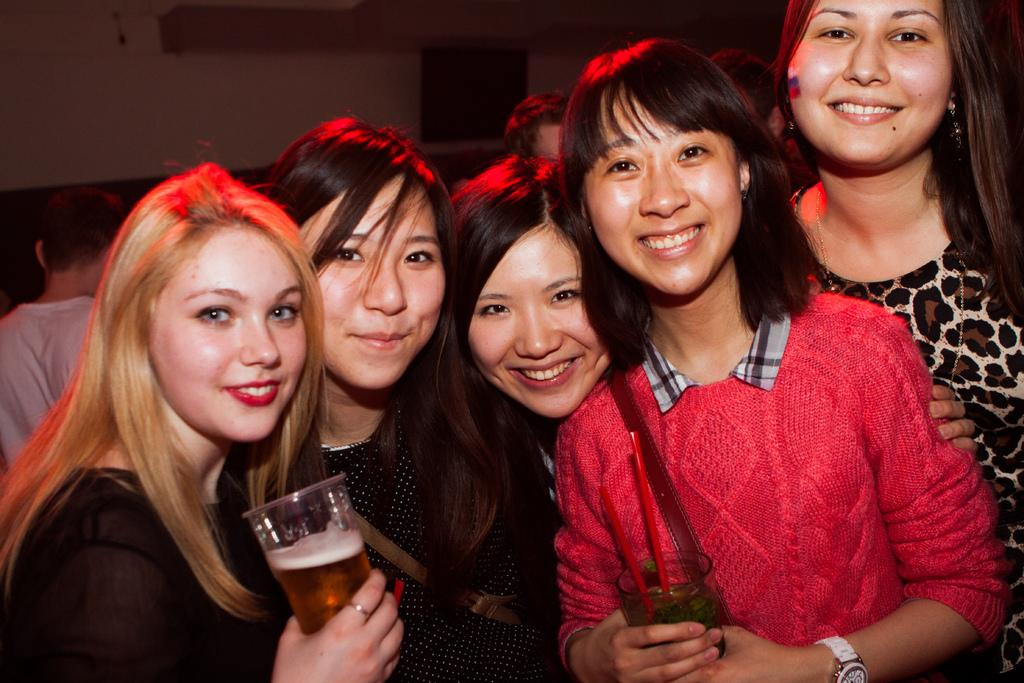How many women are in the image? There are women in the image. What are the women doing in the image? The women are standing and smiling. Can you describe the position of the woman in the corner? There is a woman in the corner of the image. What is the woman in the corner holding? The woman in the corner is holding a wine glass in her hand. What type of paste is being used by the women in the image? There is no paste visible in the image, and the women are not using any paste. Can you tell me how many airports are in the image? There are no airports present in the image. 